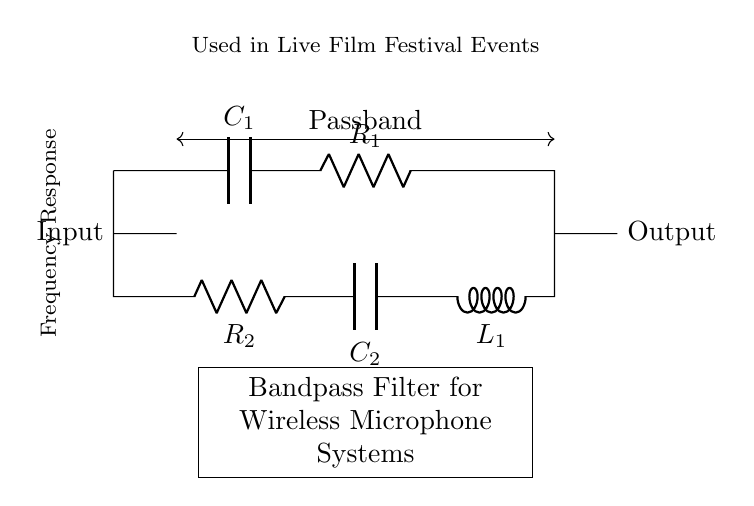What types of components are present in this circuit? The circuit consists of capacitors, resistors, and an inductor. The labels in the circuit help identify these components clearly.
Answer: capacitors, resistors, inductor What is the function of the bandpass filter? A bandpass filter allows signals within a certain frequency range to pass while attenuating signals outside that range. This is crucial for selective signal processing, especially in wireless microphone systems.
Answer: allow certain frequencies How many total resistors are in the circuit? There are two resistors present in the circuit, labeled as R1 and R2. Their positions can be identified by examining the diagram.
Answer: 2 What is the role of the inductor in this filter? The inductor is used to block high-frequency signals while allowing low-frequency signals to pass, contributing to the overall filtering behavior of the circuit.
Answer: block high frequency What does the term "passband" refer to in this context? The "passband" refers to the range of frequencies that the filter allows to pass through without significant attenuation, as indicated in the circuit's labels.
Answer: range of allowed frequencies How does the arrangement of components affect the frequency response? The specific arrangement and values of capacitors, resistors, and inductors determine the filter's cut-off frequencies and overall response, creating the desired bandpass characteristics.
Answer: determines frequency response What is the purpose of capacitors in the circuit? Capacitors in the circuit are crucial for shaping the frequency response of the filter, allowing certain frequency ranges to pass while blocking others.
Answer: shape frequency response 